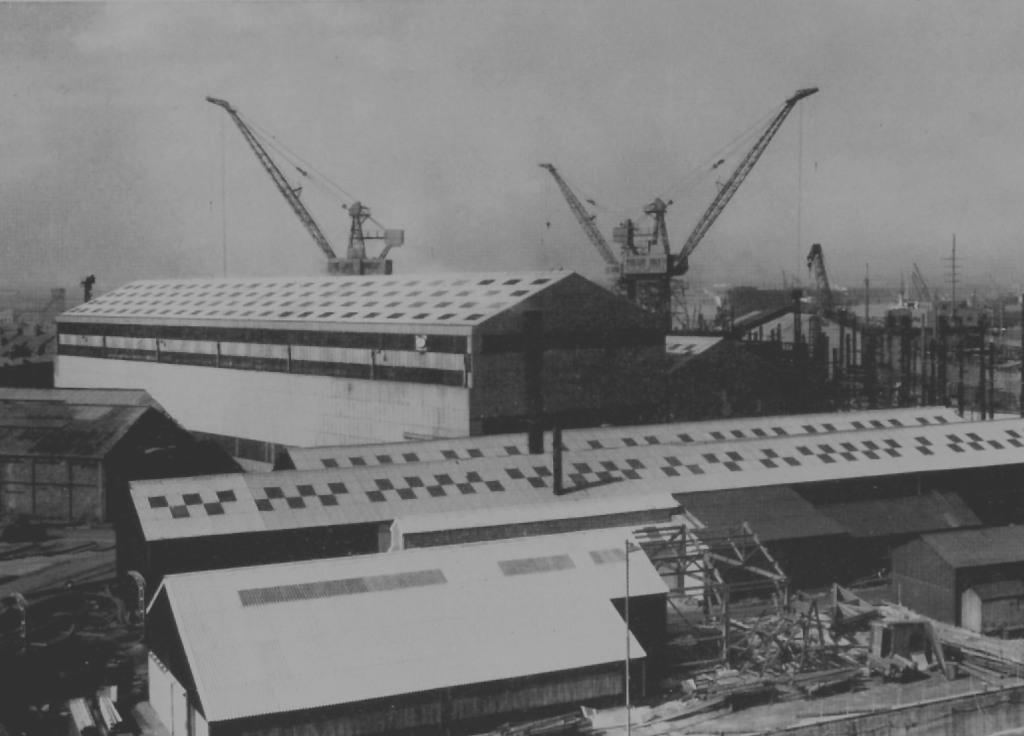What structures are located in the center of the image? There are docks in the center of the image. What other notable features can be seen in the image? There are towers in the image. How many pizzas are being served at the harbor in the image? There is no harbor or pizzas present in the image. What season is depicted in the image, given the presence of spring flowers? There is no mention of spring flowers or any seasonal indicators in the image. 